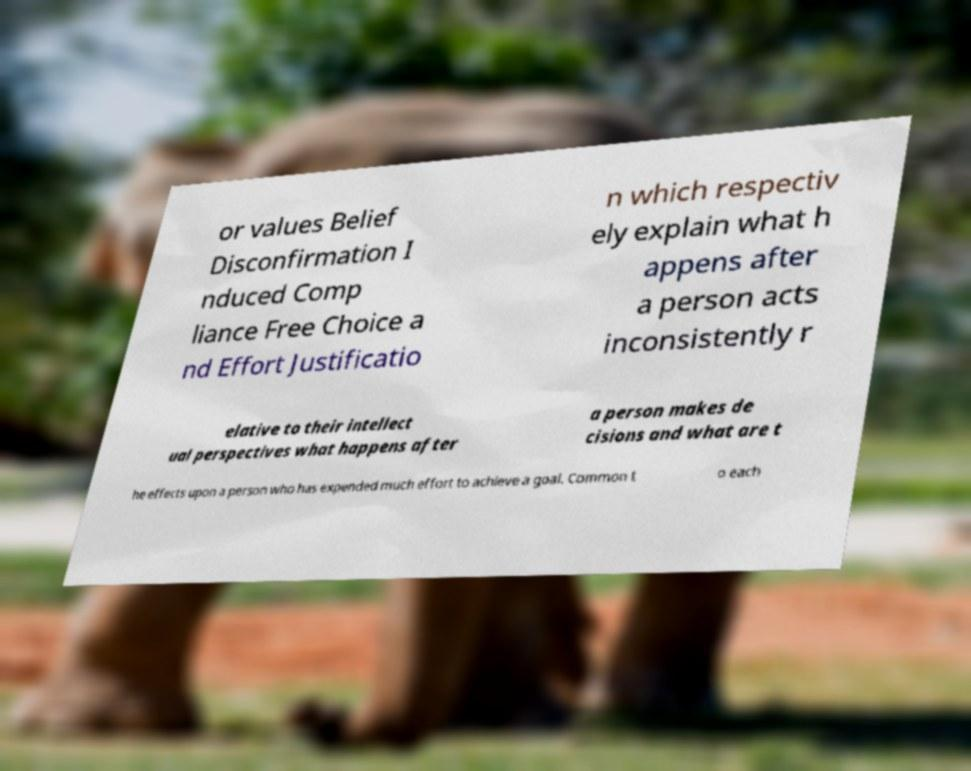What messages or text are displayed in this image? I need them in a readable, typed format. or values Belief Disconfirmation I nduced Comp liance Free Choice a nd Effort Justificatio n which respectiv ely explain what h appens after a person acts inconsistently r elative to their intellect ual perspectives what happens after a person makes de cisions and what are t he effects upon a person who has expended much effort to achieve a goal. Common t o each 